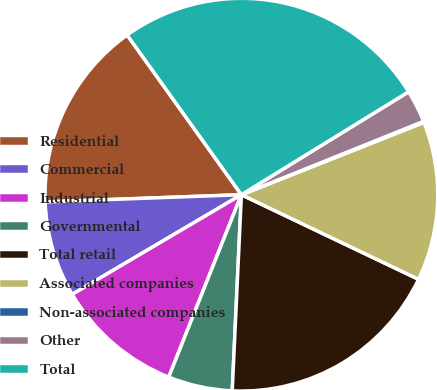<chart> <loc_0><loc_0><loc_500><loc_500><pie_chart><fcel>Residential<fcel>Commercial<fcel>Industrial<fcel>Governmental<fcel>Total retail<fcel>Associated companies<fcel>Non-associated companies<fcel>Other<fcel>Total<nl><fcel>15.7%<fcel>7.89%<fcel>10.49%<fcel>5.29%<fcel>18.65%<fcel>13.09%<fcel>0.09%<fcel>2.69%<fcel>26.1%<nl></chart> 